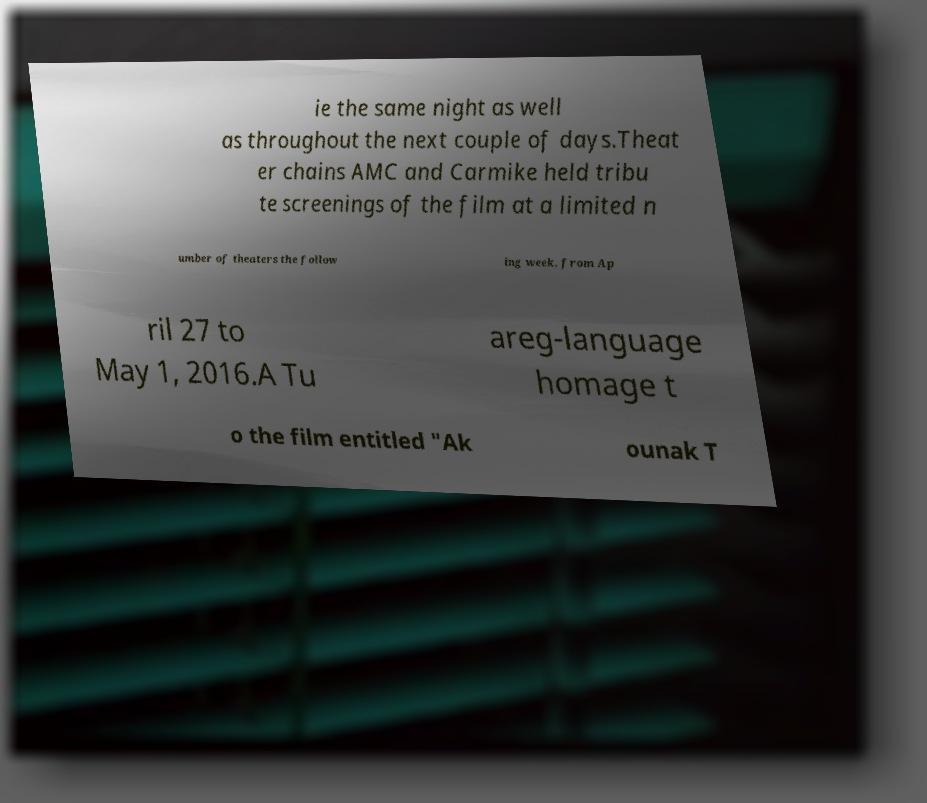I need the written content from this picture converted into text. Can you do that? ie the same night as well as throughout the next couple of days.Theat er chains AMC and Carmike held tribu te screenings of the film at a limited n umber of theaters the follow ing week, from Ap ril 27 to May 1, 2016.A Tu areg-language homage t o the film entitled "Ak ounak T 